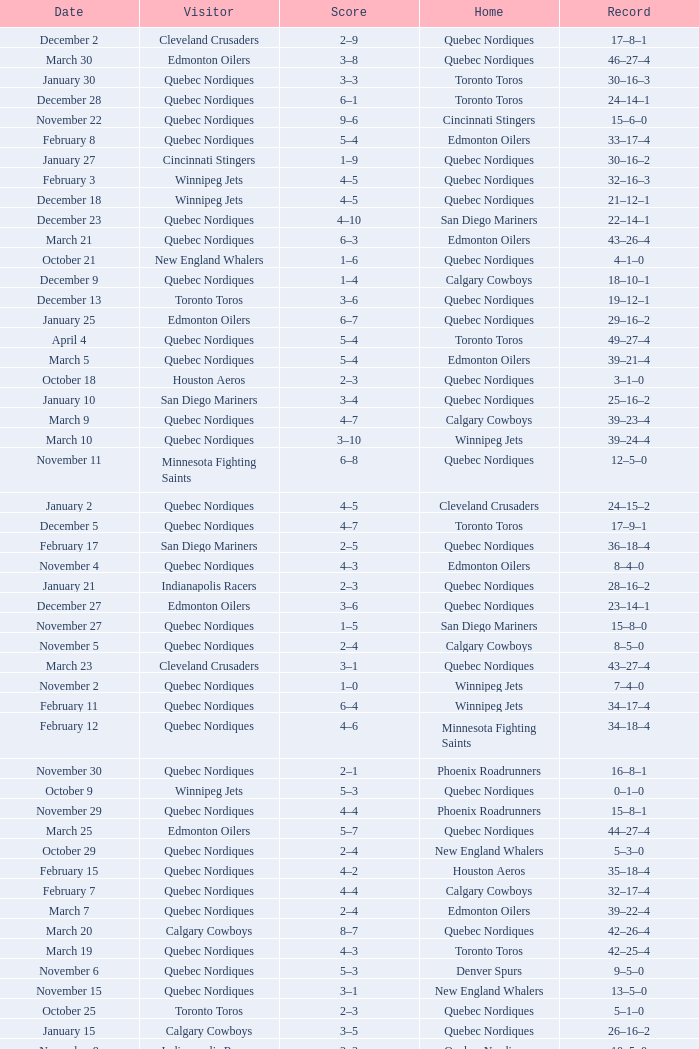What was the date of the game with a score of 2–1? November 30. 